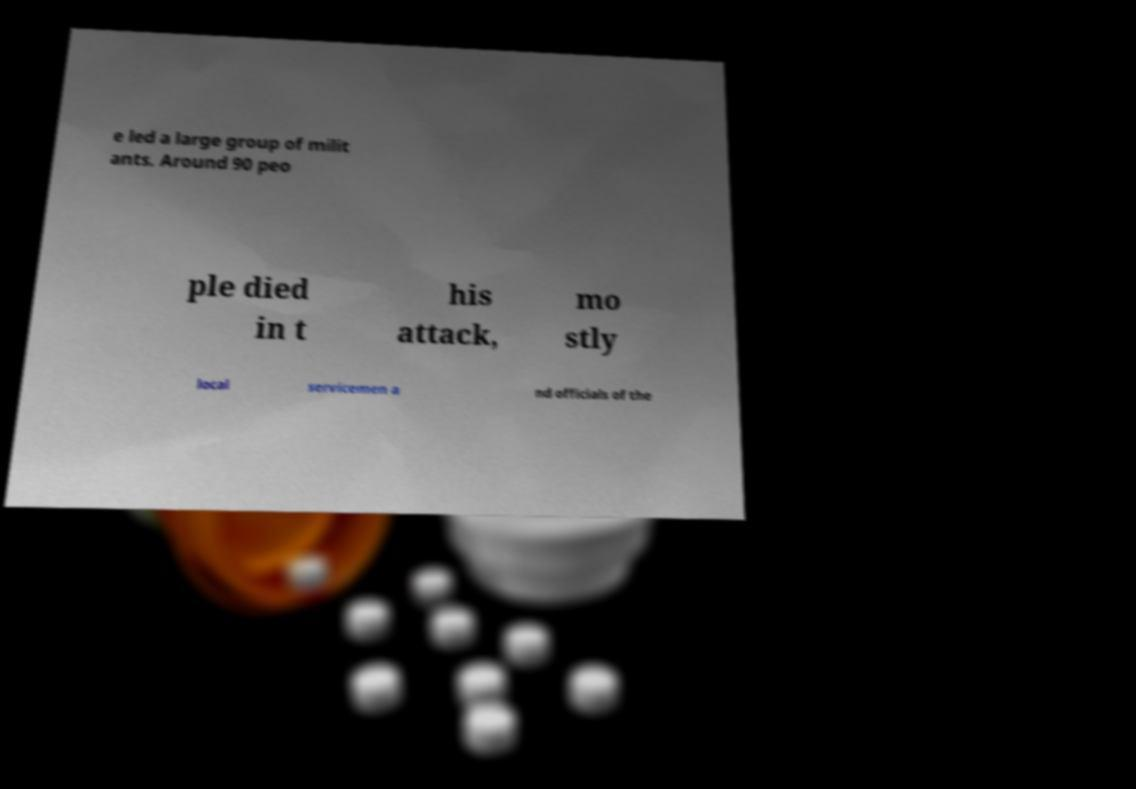There's text embedded in this image that I need extracted. Can you transcribe it verbatim? e led a large group of milit ants. Around 90 peo ple died in t his attack, mo stly local servicemen a nd officials of the 